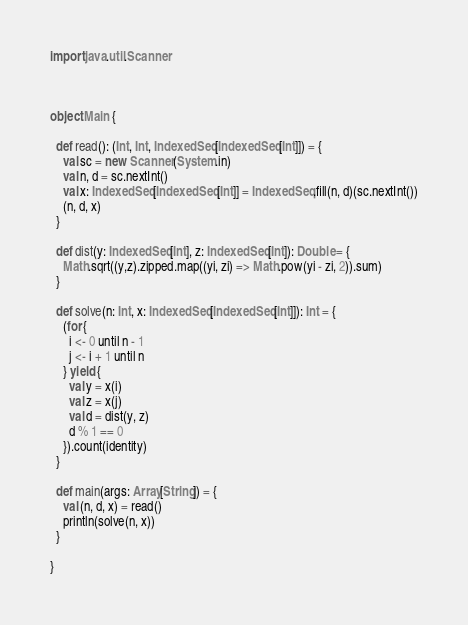<code> <loc_0><loc_0><loc_500><loc_500><_Scala_>import java.util.Scanner



object Main {

  def read(): (Int, Int, IndexedSeq[IndexedSeq[Int]]) = {
    val sc = new Scanner(System.in)
    val n, d = sc.nextInt()
    val x: IndexedSeq[IndexedSeq[Int]] = IndexedSeq.fill(n, d)(sc.nextInt())
    (n, d, x)
  }

  def dist(y: IndexedSeq[Int], z: IndexedSeq[Int]): Double = {
    Math.sqrt((y,z).zipped.map((yi, zi) => Math.pow(yi - zi, 2)).sum)
  }

  def solve(n: Int, x: IndexedSeq[IndexedSeq[Int]]): Int = {
    (for {
      i <- 0 until n - 1
      j <- i + 1 until n
    } yield {
      val y = x(i)
      val z = x(j)
      val d = dist(y, z)
      d % 1 == 0
    }).count(identity)
  }

  def main(args: Array[String]) = {
    val (n, d, x) = read()
    println(solve(n, x))
  }

}</code> 